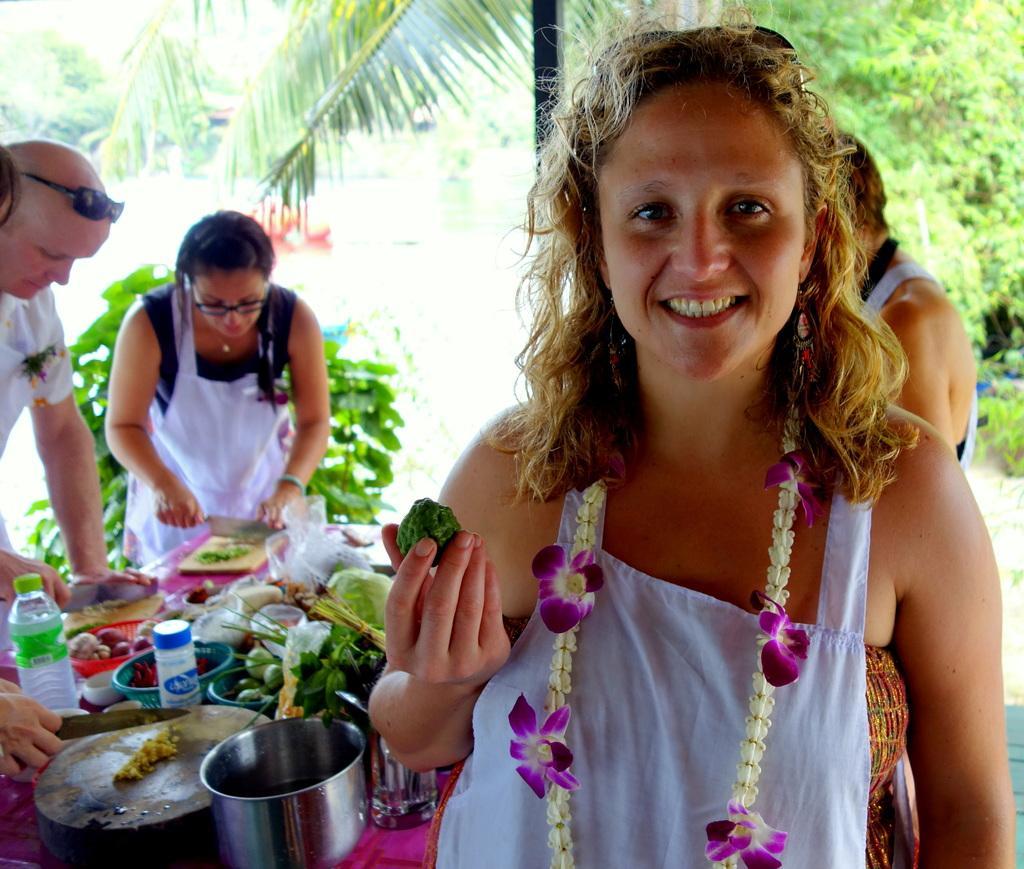Can you describe this image briefly? In this picture we can see a woman wearing a garland and smiling. She is holding a food item in her hand. There is a bottle, kitchen vessels, food items in the baskets, wooden objects and other objects are visible on the table. We can see a man and a woman holding knives in their hands. There is a rod. We can see some plants and trees in the background. 